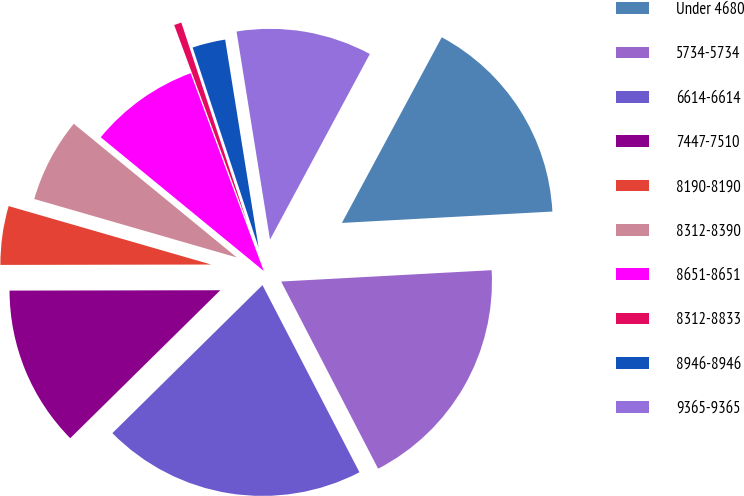Convert chart. <chart><loc_0><loc_0><loc_500><loc_500><pie_chart><fcel>Under 4680<fcel>5734-5734<fcel>6614-6614<fcel>7447-7510<fcel>8190-8190<fcel>8312-8390<fcel>8651-8651<fcel>8312-8833<fcel>8946-8946<fcel>9365-9365<nl><fcel>16.29%<fcel>18.25%<fcel>20.22%<fcel>12.36%<fcel>4.5%<fcel>6.46%<fcel>8.43%<fcel>0.57%<fcel>2.53%<fcel>10.39%<nl></chart> 